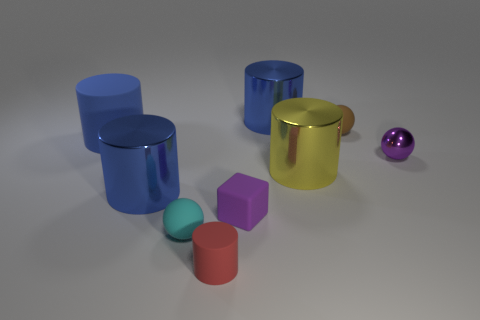Are there more tiny balls that are left of the purple shiny sphere than small objects that are on the right side of the small brown thing?
Offer a very short reply. Yes. How many small brown things are the same material as the purple block?
Give a very brief answer. 1. There is a tiny matte thing that is right of the small cube; does it have the same shape as the small purple object to the left of the brown rubber object?
Ensure brevity in your answer.  No. There is a shiny thing to the right of the small brown matte ball; what is its color?
Your response must be concise. Purple. Are there any tiny purple metallic things that have the same shape as the red rubber object?
Your response must be concise. No. What material is the large yellow cylinder?
Give a very brief answer. Metal. There is a shiny thing that is behind the yellow metallic thing and to the left of the small purple sphere; what is its size?
Provide a short and direct response. Large. There is a tiny sphere that is the same color as the block; what is its material?
Keep it short and to the point. Metal. How many small brown matte spheres are there?
Offer a terse response. 1. Is the number of brown rubber objects less than the number of big brown cylinders?
Keep it short and to the point. No. 